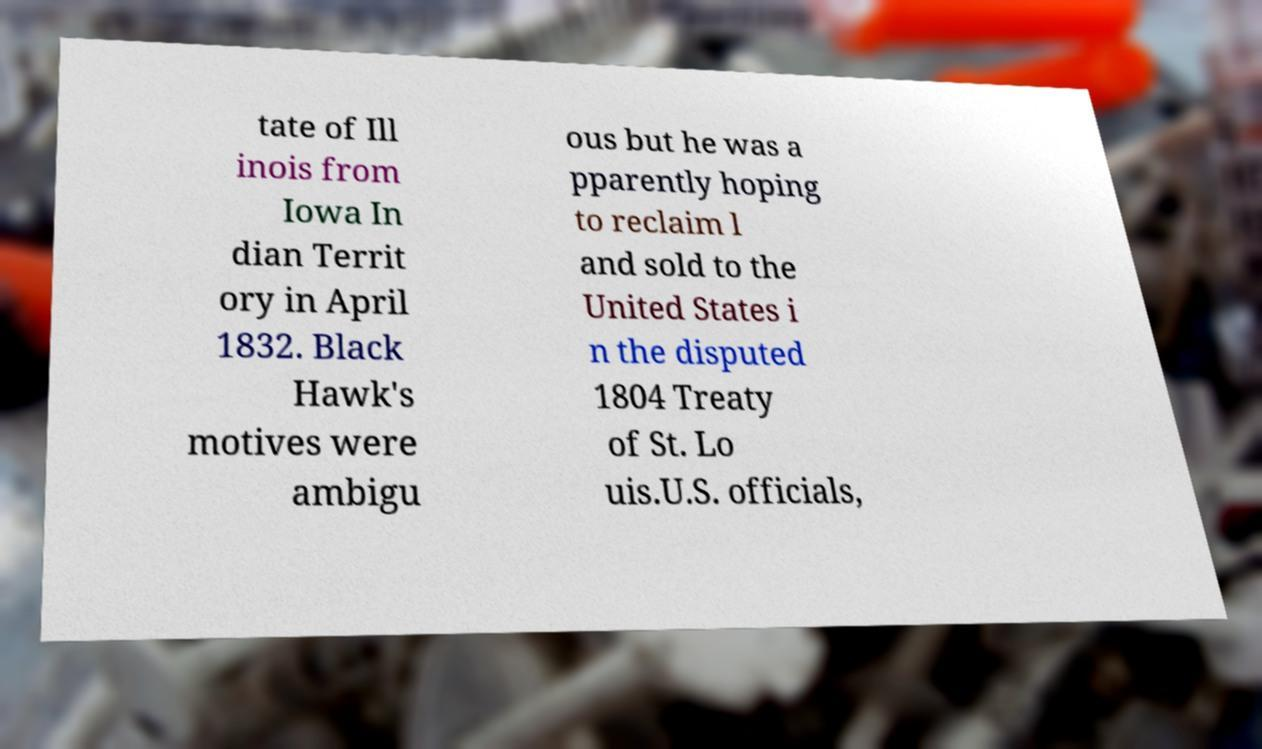Could you assist in decoding the text presented in this image and type it out clearly? tate of Ill inois from Iowa In dian Territ ory in April 1832. Black Hawk's motives were ambigu ous but he was a pparently hoping to reclaim l and sold to the United States i n the disputed 1804 Treaty of St. Lo uis.U.S. officials, 